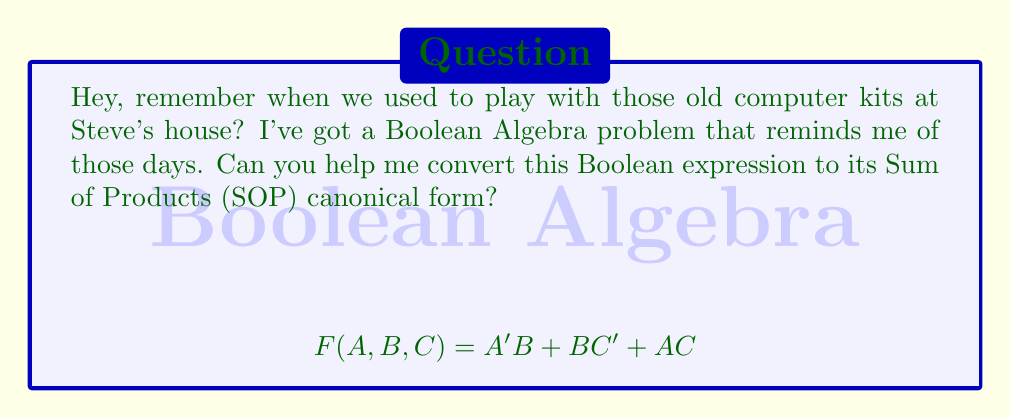Teach me how to tackle this problem. Sure! Let's convert this Boolean expression to Sum of Products (SOP) canonical form step by step:

1) First, we need to expand each term to include all variables:

   $A'B = A'B(C+C') = A'BC + A'BC'$
   $BC' = (A+A')BC' = ABC' + A'BC'$
   $AC = AC(B+B') = ABC + ABC'$

2) Now our expression looks like:

   $F(A,B,C) = A'BC + A'BC' + ABC' + A'BC' + ABC + ABC'$

3) Simplify by combining like terms:

   $F(A,B,C) = A'BC + A'BC' + ABC' + ABC$

4) This is now in SOP canonical form, as each term contains all variables (or their complements) and is a product (AND) of these literals.

5) We can verify that each term represents a minterm:

   $A'BC = m_4$
   $A'BC' = m_5$
   $ABC' = m_6$
   $ABC = m_7$

Therefore, the final SOP canonical form can be written as:

$$ F(A,B,C) = \sum m(4,5,6,7) $$
Answer: $F(A,B,C) = A'BC + A'BC' + ABC' + ABC = \sum m(4,5,6,7)$ 